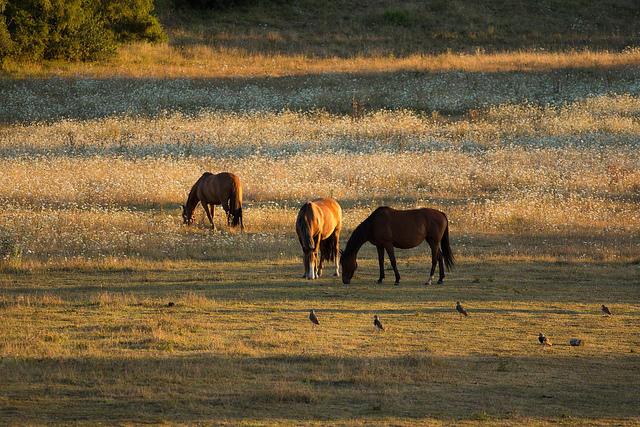Overcast or sunny?
Be succinct. Sunny. Are the horses thoroughbred?
Short answer required. Yes. How many birds are there?
Quick response, please. 5. How many horses are there?
Quick response, please. 3. Is there a lot of grass in this picture?
Answer briefly. Yes. 